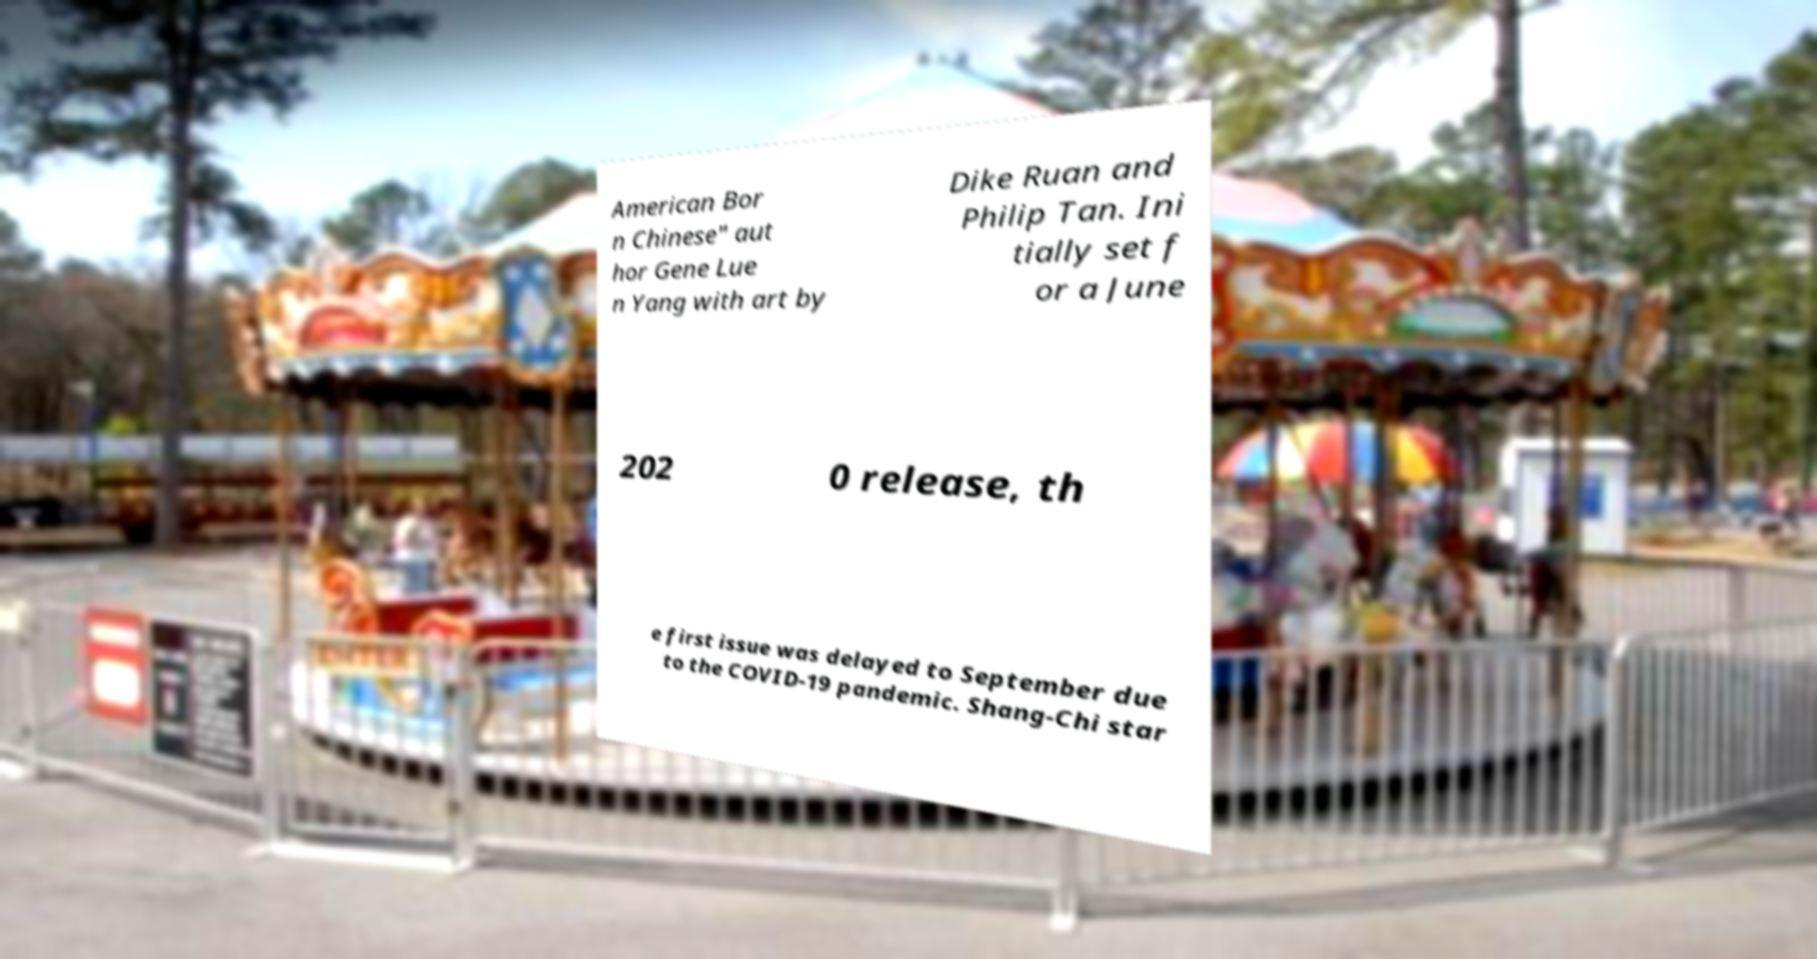Could you extract and type out the text from this image? American Bor n Chinese" aut hor Gene Lue n Yang with art by Dike Ruan and Philip Tan. Ini tially set f or a June 202 0 release, th e first issue was delayed to September due to the COVID-19 pandemic. Shang-Chi star 